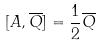<formula> <loc_0><loc_0><loc_500><loc_500>[ A , \overline { Q } ] = \frac { 1 } { 2 } \overline { Q }</formula> 